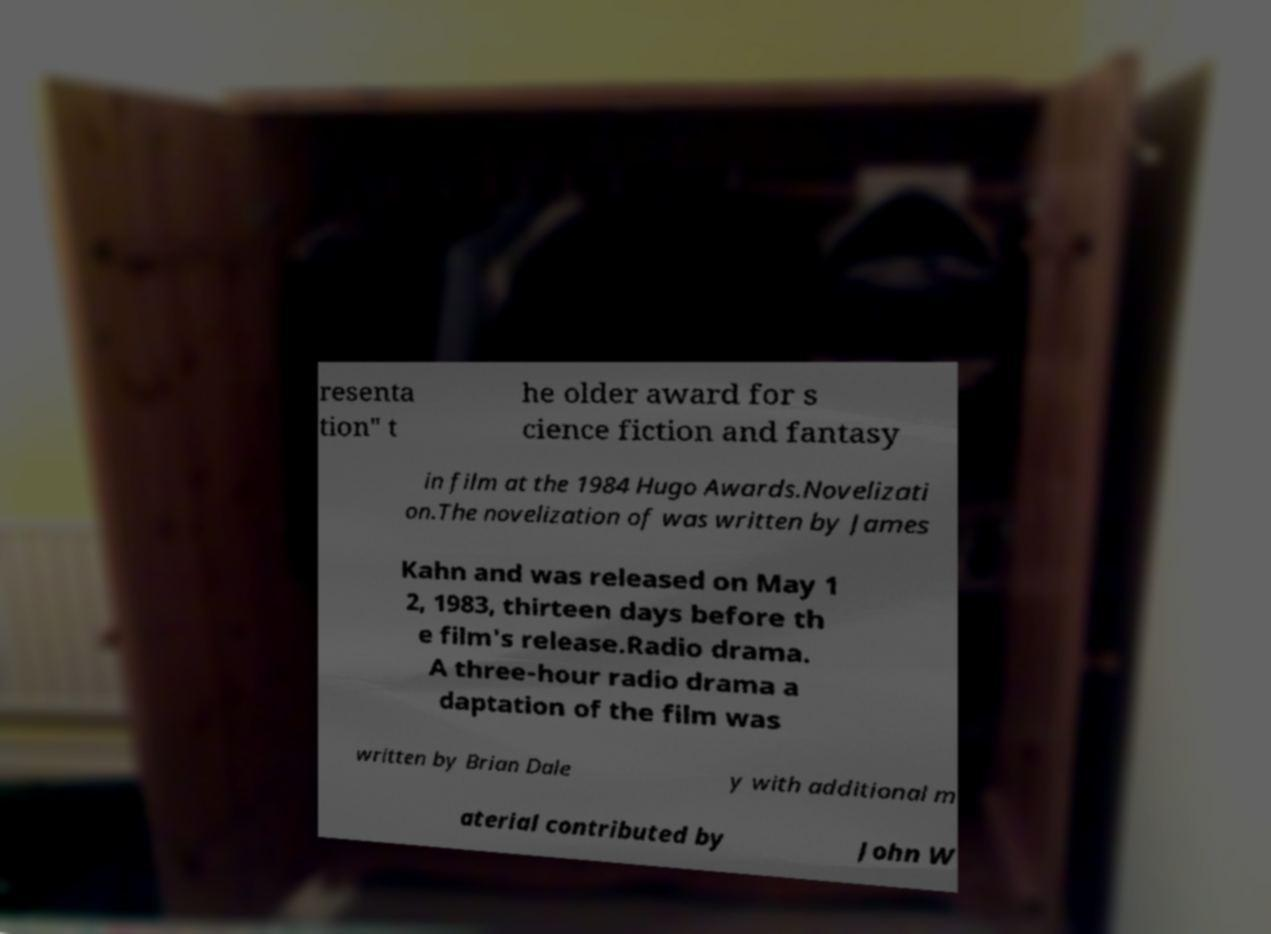There's text embedded in this image that I need extracted. Can you transcribe it verbatim? resenta tion" t he older award for s cience fiction and fantasy in film at the 1984 Hugo Awards.Novelizati on.The novelization of was written by James Kahn and was released on May 1 2, 1983, thirteen days before th e film's release.Radio drama. A three-hour radio drama a daptation of the film was written by Brian Dale y with additional m aterial contributed by John W 